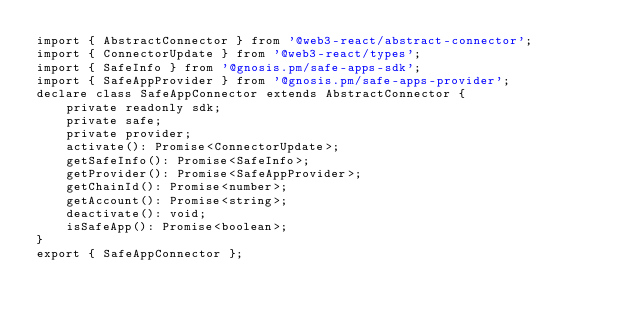Convert code to text. <code><loc_0><loc_0><loc_500><loc_500><_TypeScript_>import { AbstractConnector } from '@web3-react/abstract-connector';
import { ConnectorUpdate } from '@web3-react/types';
import { SafeInfo } from '@gnosis.pm/safe-apps-sdk';
import { SafeAppProvider } from '@gnosis.pm/safe-apps-provider';
declare class SafeAppConnector extends AbstractConnector {
    private readonly sdk;
    private safe;
    private provider;
    activate(): Promise<ConnectorUpdate>;
    getSafeInfo(): Promise<SafeInfo>;
    getProvider(): Promise<SafeAppProvider>;
    getChainId(): Promise<number>;
    getAccount(): Promise<string>;
    deactivate(): void;
    isSafeApp(): Promise<boolean>;
}
export { SafeAppConnector };
</code> 